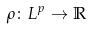Convert formula to latex. <formula><loc_0><loc_0><loc_500><loc_500>\rho \colon L ^ { p } \rightarrow \mathbb { R }</formula> 